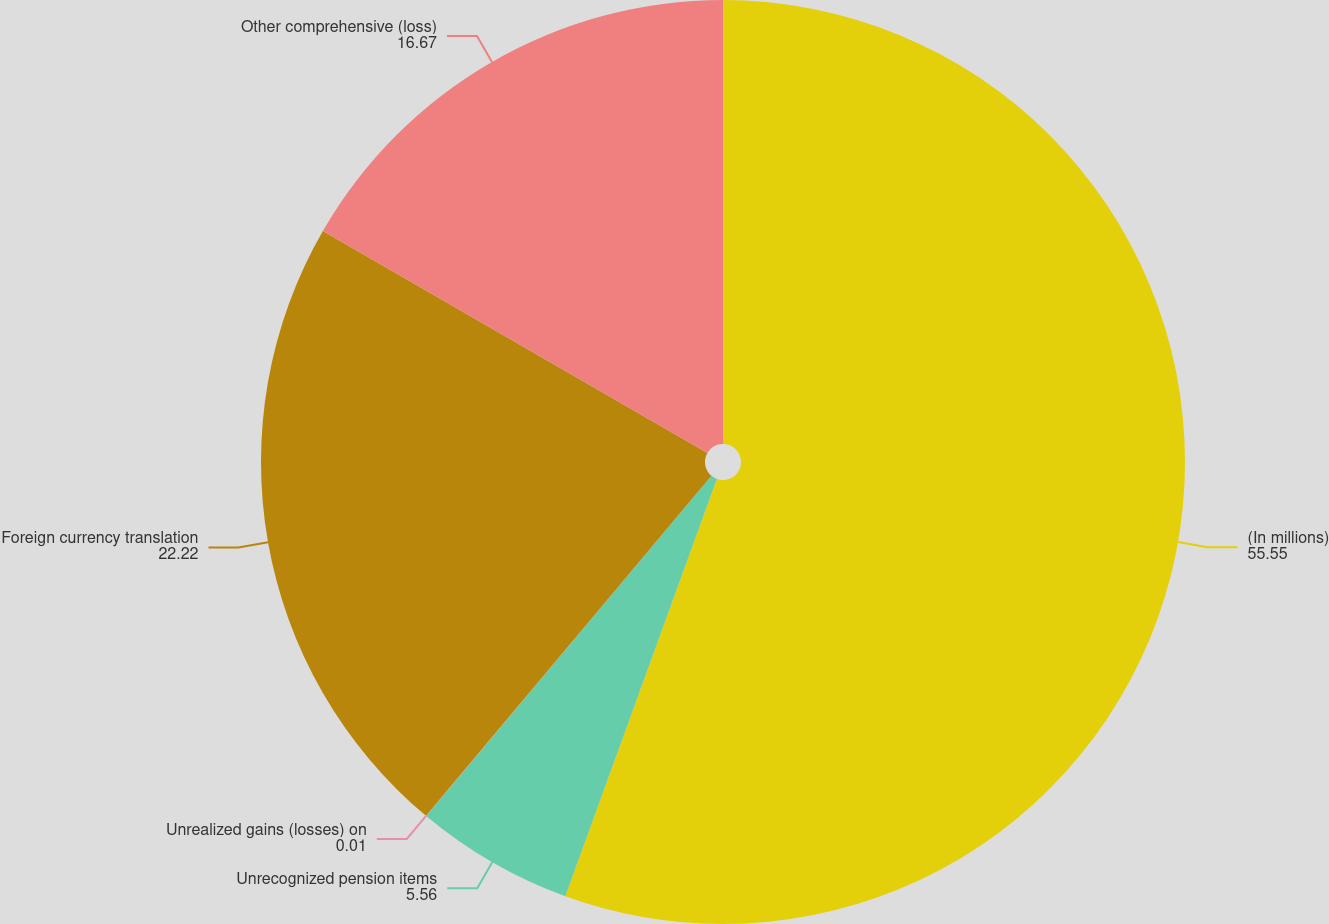Convert chart to OTSL. <chart><loc_0><loc_0><loc_500><loc_500><pie_chart><fcel>(In millions)<fcel>Unrecognized pension items<fcel>Unrealized gains (losses) on<fcel>Foreign currency translation<fcel>Other comprehensive (loss)<nl><fcel>55.55%<fcel>5.56%<fcel>0.01%<fcel>22.22%<fcel>16.67%<nl></chart> 